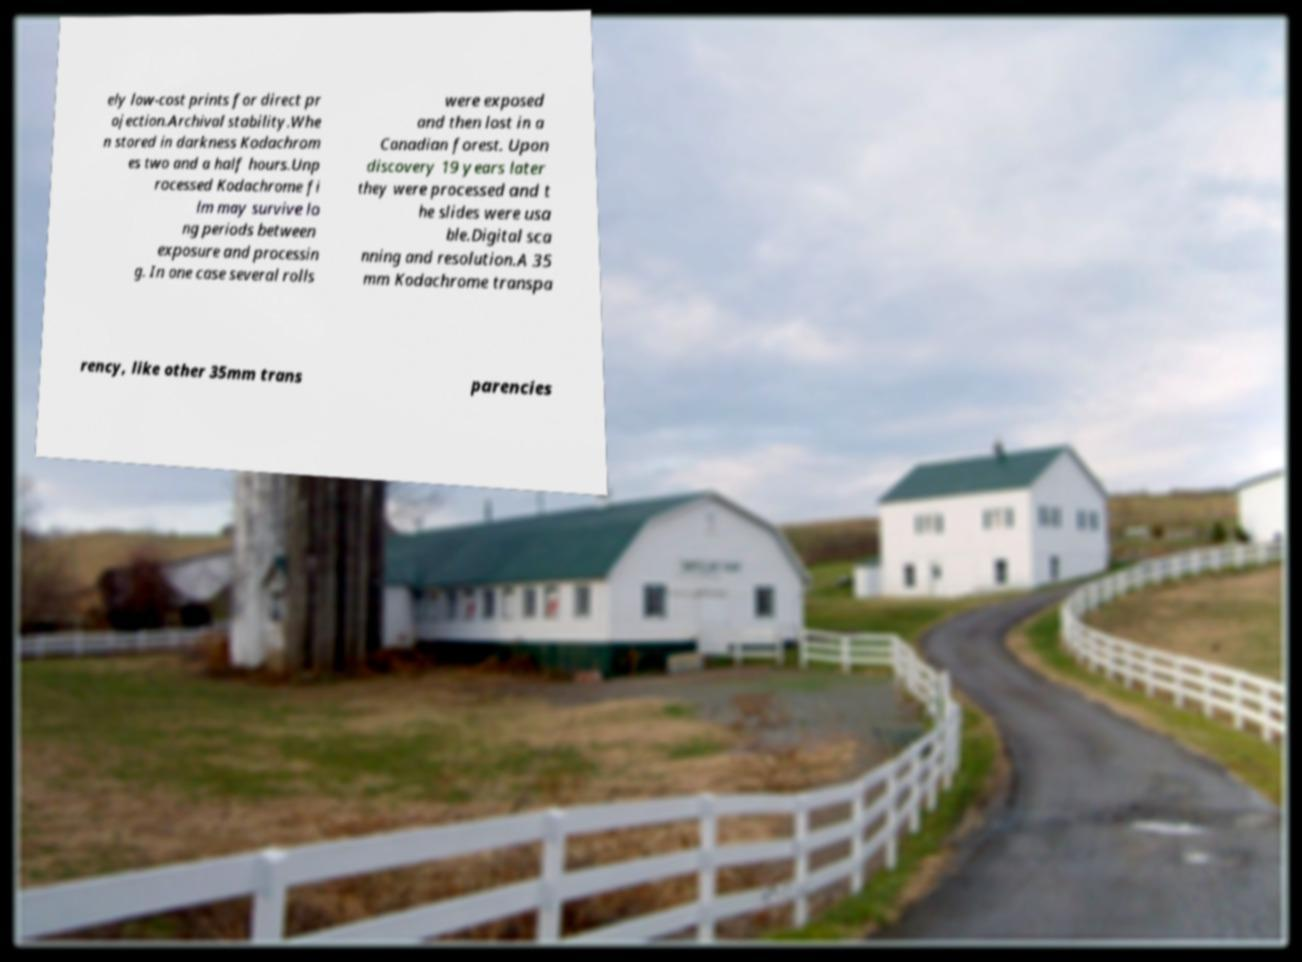Could you assist in decoding the text presented in this image and type it out clearly? ely low-cost prints for direct pr ojection.Archival stability.Whe n stored in darkness Kodachrom es two and a half hours.Unp rocessed Kodachrome fi lm may survive lo ng periods between exposure and processin g. In one case several rolls were exposed and then lost in a Canadian forest. Upon discovery 19 years later they were processed and t he slides were usa ble.Digital sca nning and resolution.A 35 mm Kodachrome transpa rency, like other 35mm trans parencies 